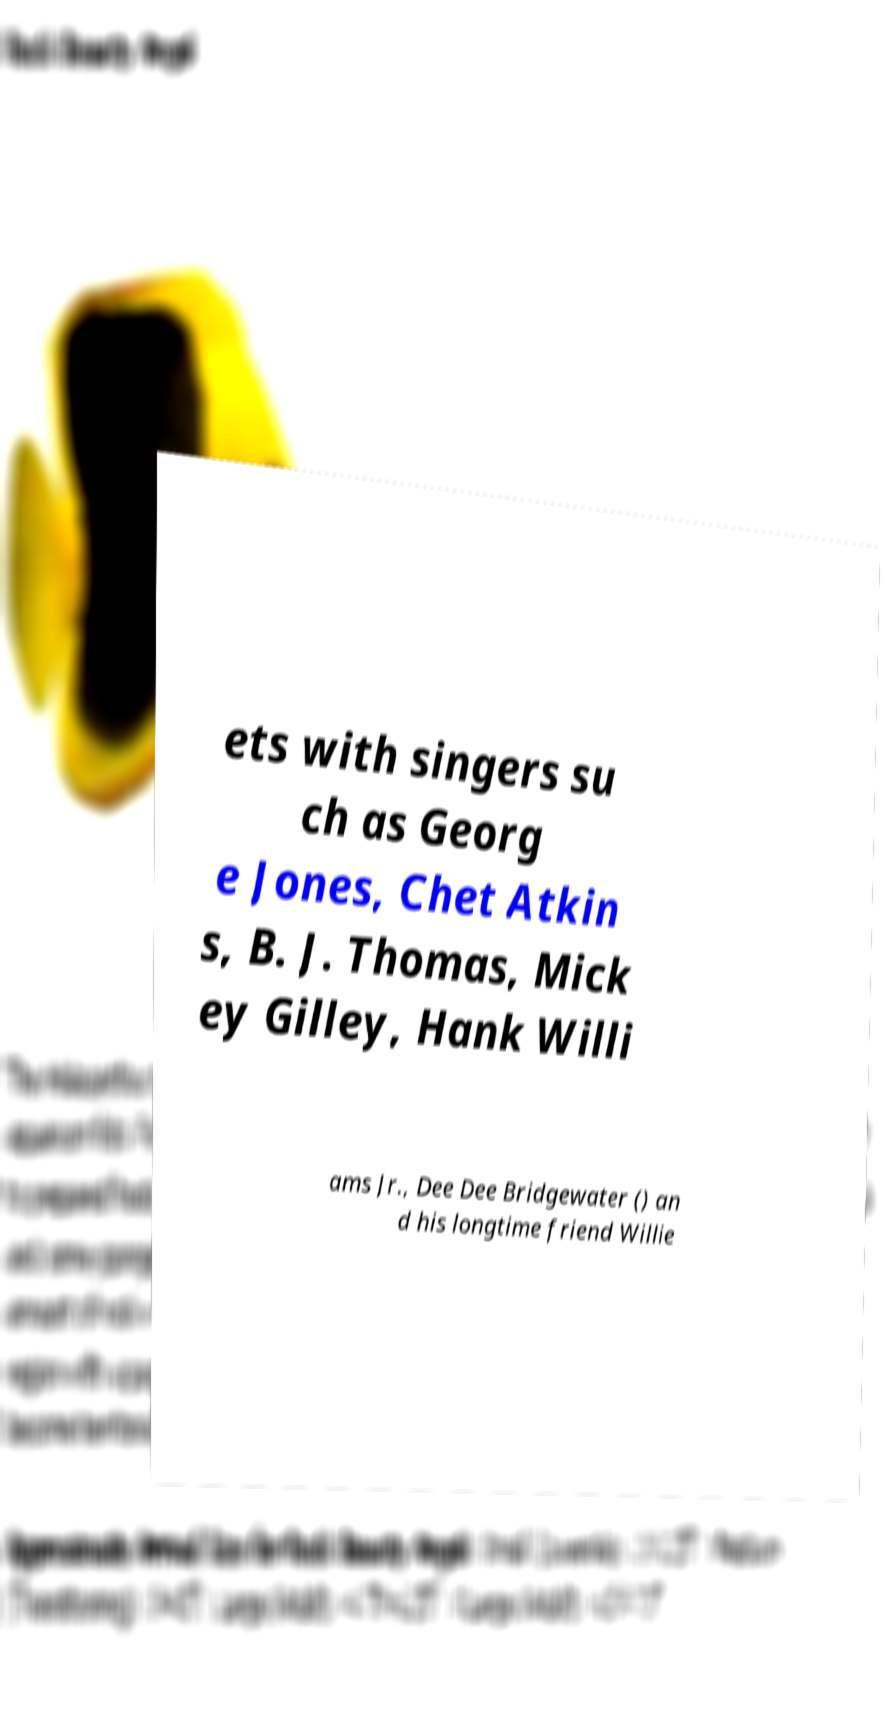I need the written content from this picture converted into text. Can you do that? ets with singers su ch as Georg e Jones, Chet Atkin s, B. J. Thomas, Mick ey Gilley, Hank Willi ams Jr., Dee Dee Bridgewater () an d his longtime friend Willie 